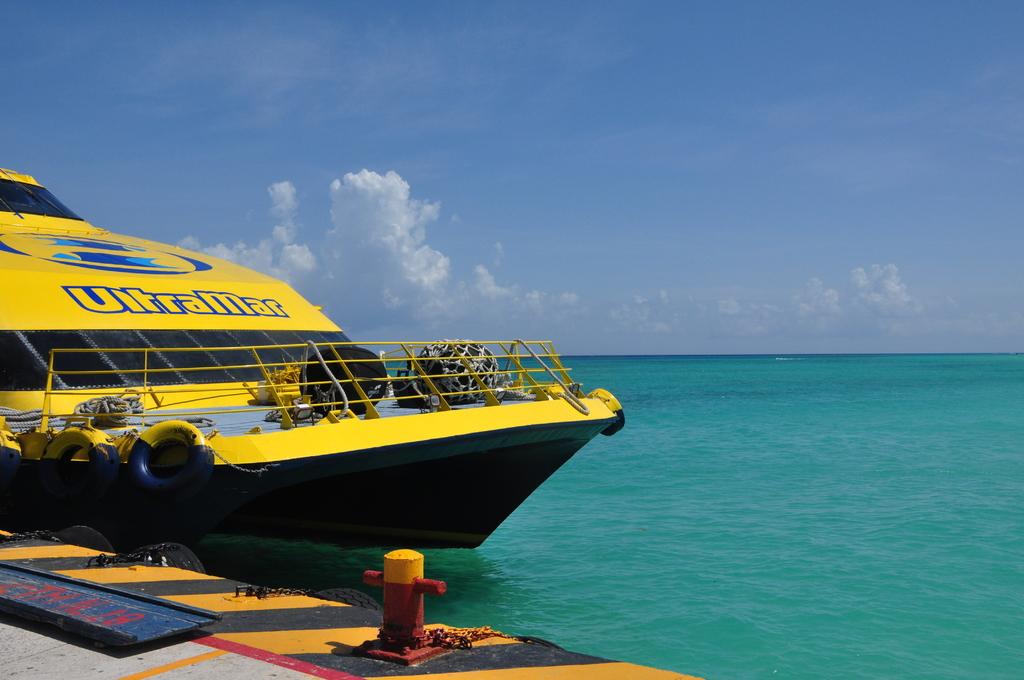What is the name of the yellow boat?
Your answer should be compact. Ultramar. Is ultramar outlined in blue?
Give a very brief answer. Yes. 